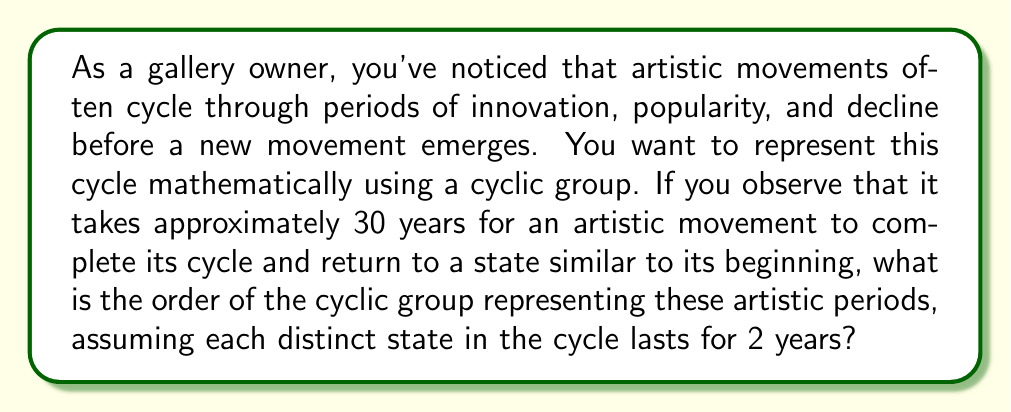Teach me how to tackle this problem. To solve this problem, we need to understand the concept of cyclic groups and how they relate to the given scenario:

1) A cyclic group is a group that can be generated by a single element. The order of a cyclic group is the number of distinct elements in the group.

2) In this case, each distinct state in the artistic cycle lasts for 2 years.

3) The total cycle takes 30 years to complete.

4) To find the order of the cyclic group, we need to determine how many distinct states exist in one complete cycle.

5) We can calculate this by dividing the total cycle time by the duration of each state:

   $$\text{Number of distinct states} = \frac{\text{Total cycle time}}{\text{Duration of each state}} = \frac{30 \text{ years}}{2 \text{ years}} = 15$$

6) Therefore, the cyclic group representing these artistic periods has 15 distinct elements.

7) We can represent this group as $C_{15}$ or $\mathbb{Z}/15\mathbb{Z}$.

8) The elements of this group can be thought of as the residue classes modulo 15: $\{0, 1, 2, ..., 14\}$, where each number represents a distinct 2-year state in the 30-year cycle.

9) The order of a cyclic group is equal to the number of its distinct elements.

Thus, the order of this cyclic group is 15.
Answer: The order of the cyclic group representing the artistic periods is 15. 